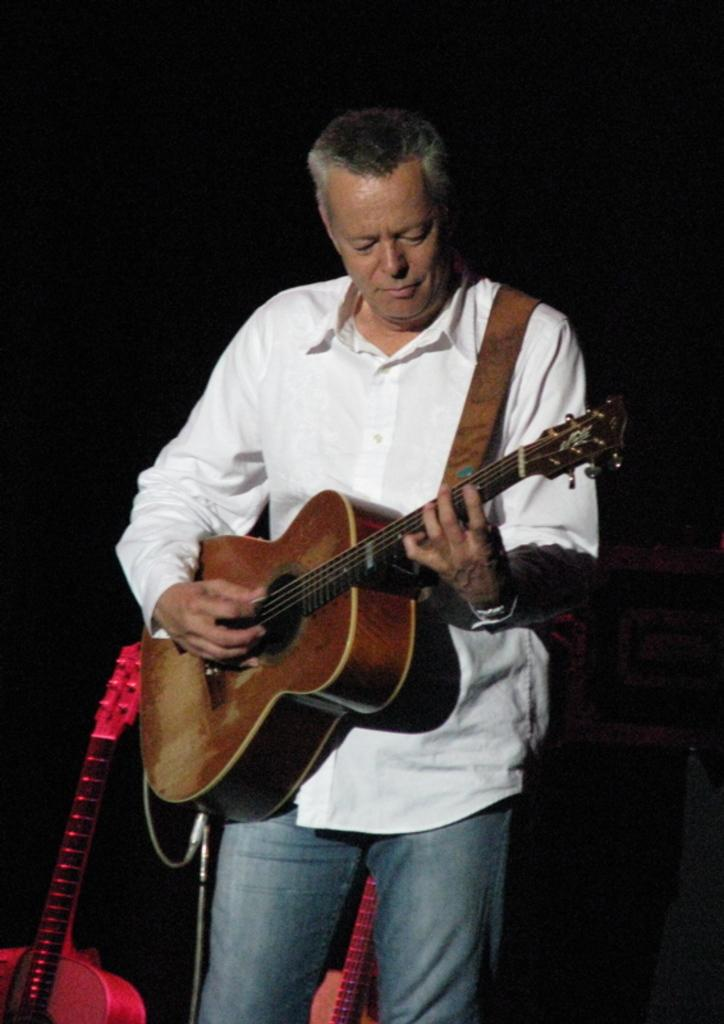What is the person in the image doing? The person is playing a guitar. What is the person wearing in the image? The person is wearing a white shirt and blue jeans. How many guitars can be seen in the image? There are two guitars placed behind the person. What does the person's father say about the guitar playing in the image? There is no mention of the person's father or any dialogue in the image, so it cannot be determined what the father might say about the guitar playing. 